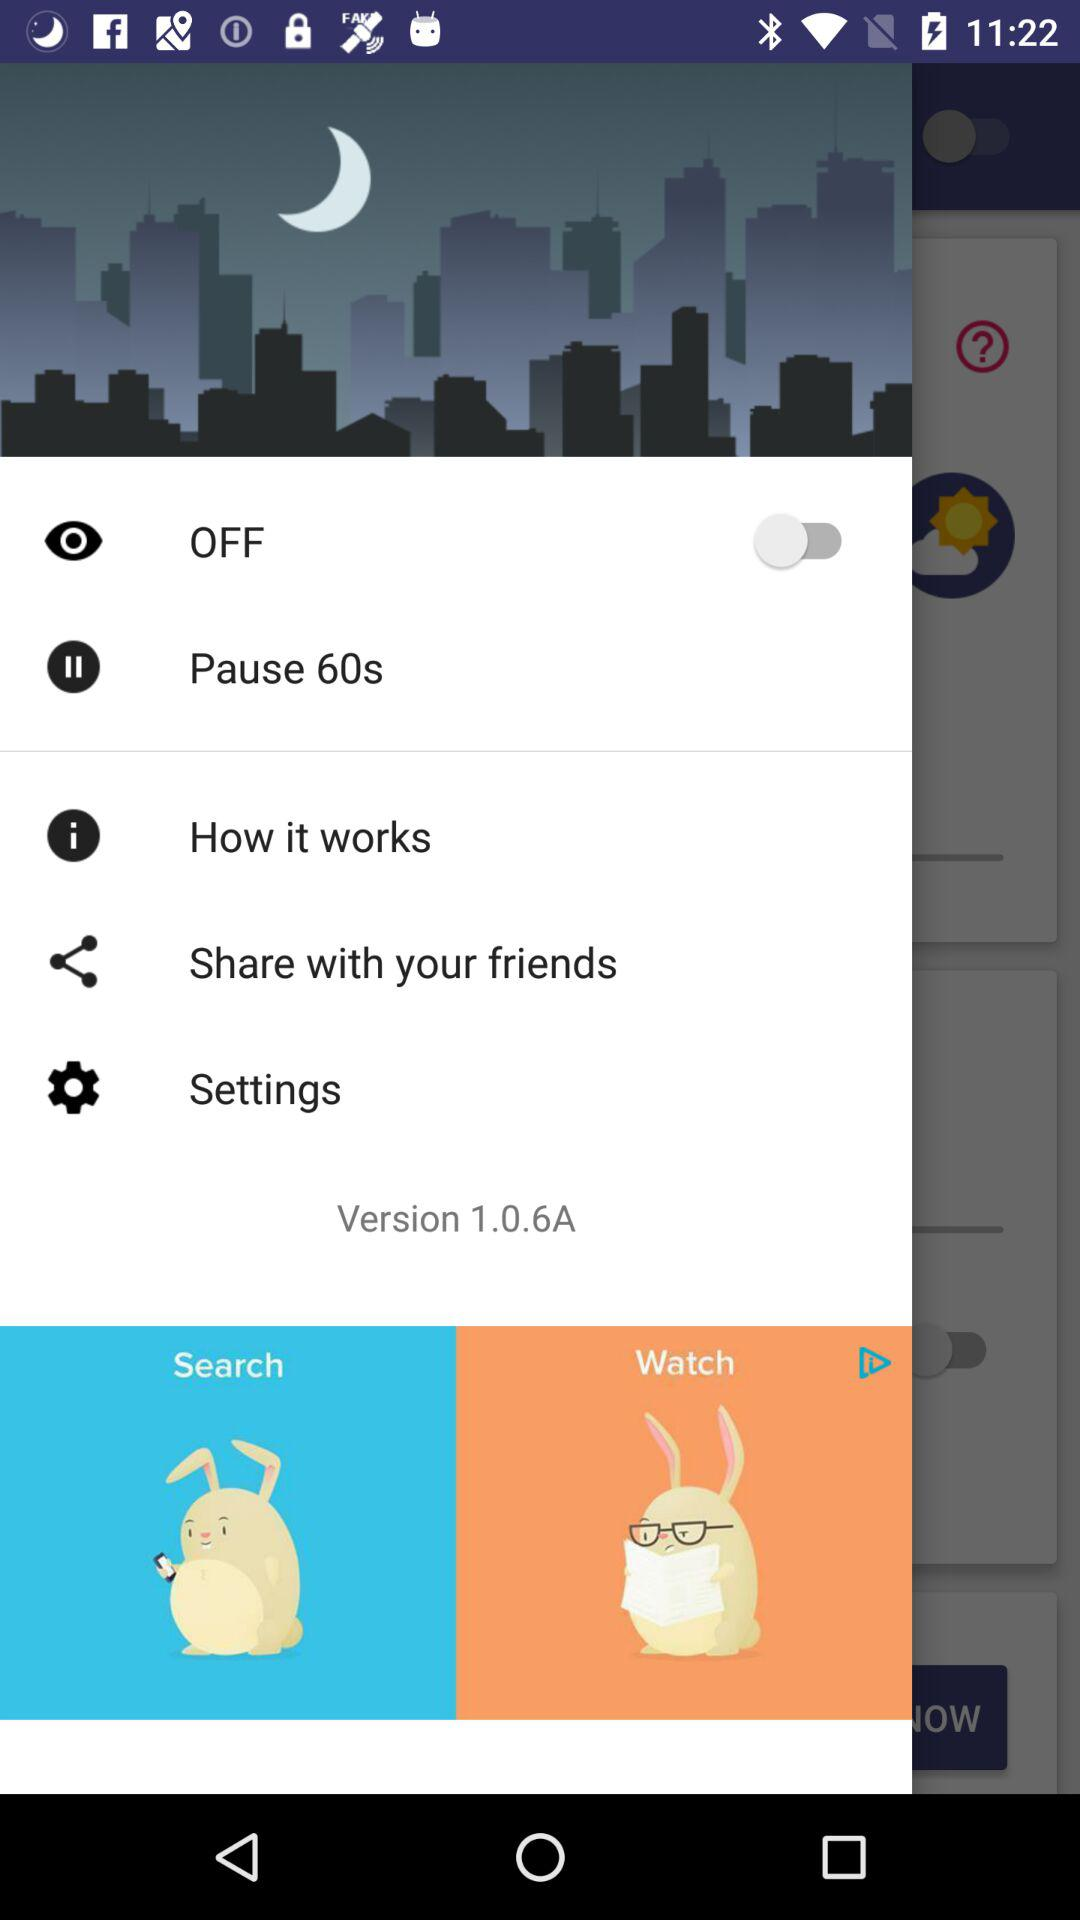How many seconds are set for the pause?
When the provided information is insufficient, respond with <no answer>. <no answer> 